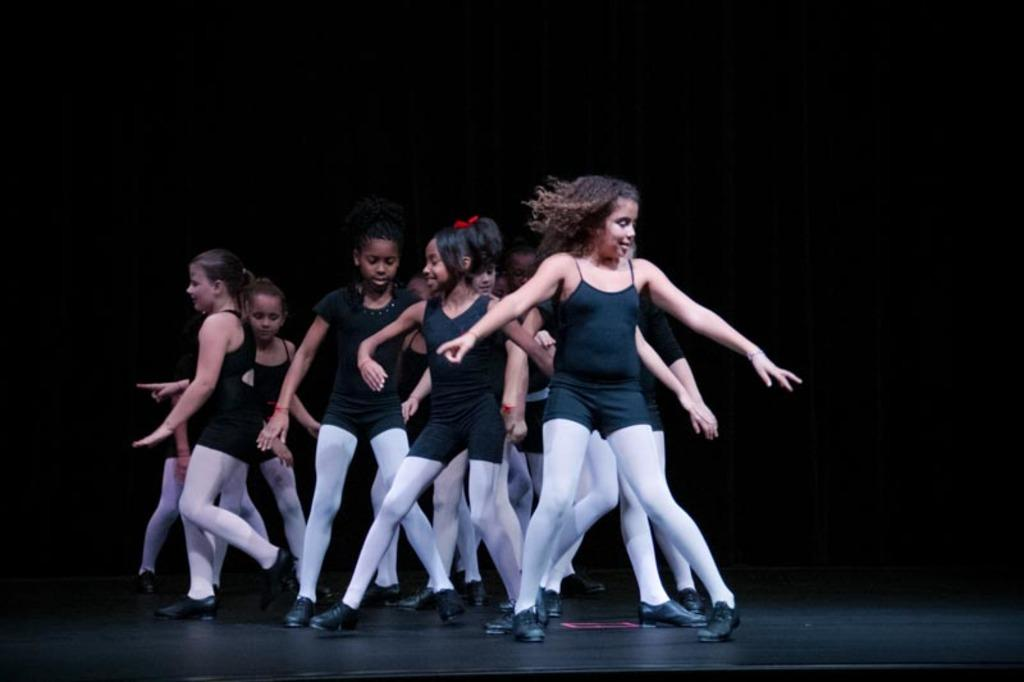How many individuals are present in the image? There is a group of people in the image. What is the position of the people in the image? The people are standing on the floor. What type of toad can be seen in the image? There is no toad present in the image. How does the society depicted in the image function? The image does not depict a society, so it is not possible to determine how it functions. 